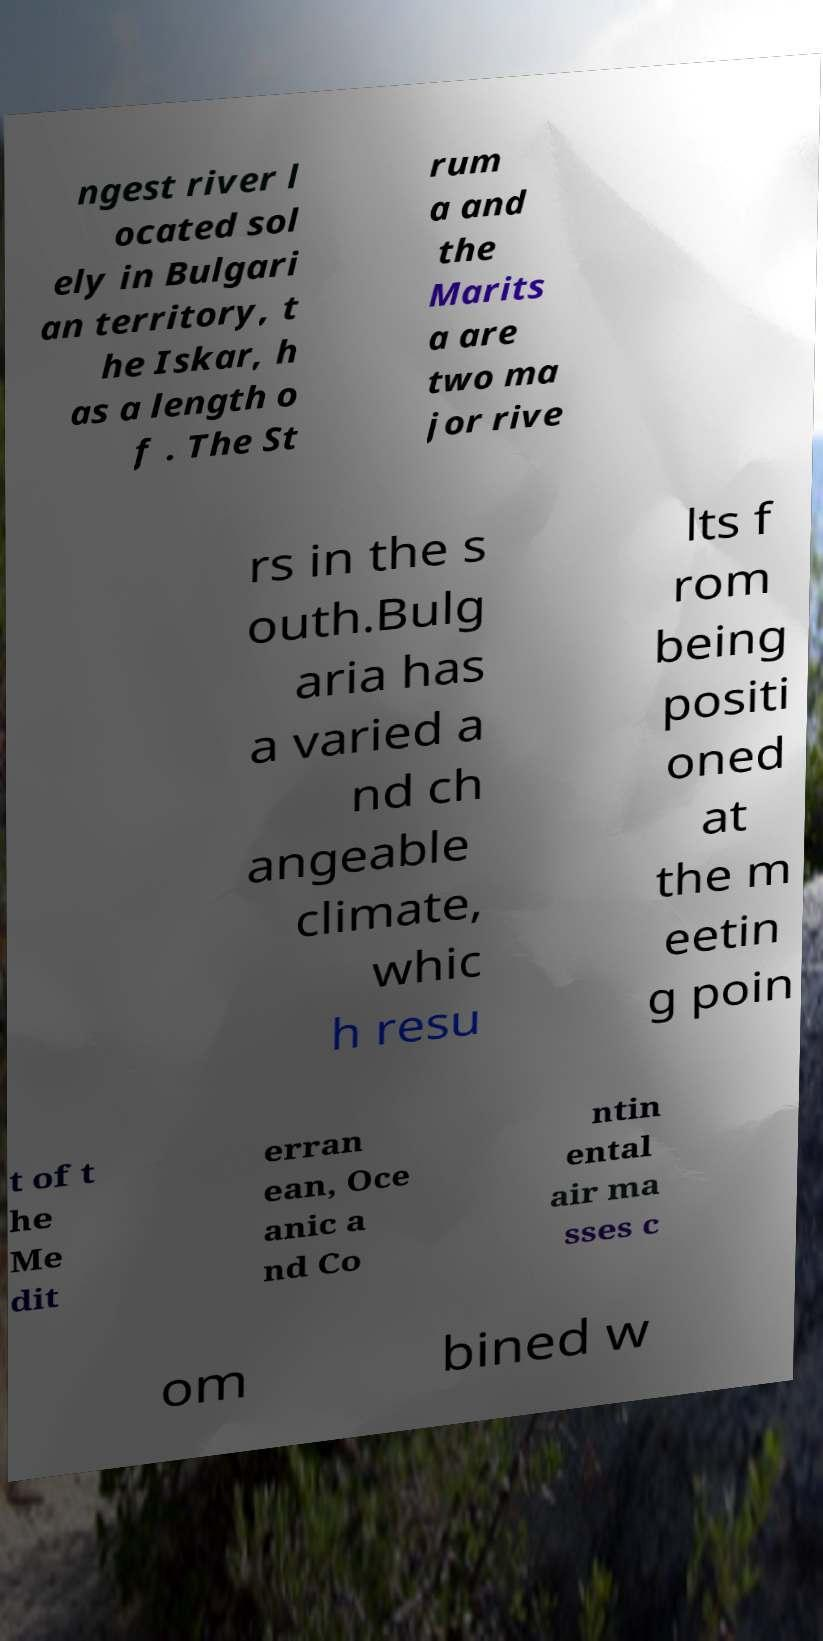Could you assist in decoding the text presented in this image and type it out clearly? ngest river l ocated sol ely in Bulgari an territory, t he Iskar, h as a length o f . The St rum a and the Marits a are two ma jor rive rs in the s outh.Bulg aria has a varied a nd ch angeable climate, whic h resu lts f rom being positi oned at the m eetin g poin t of t he Me dit erran ean, Oce anic a nd Co ntin ental air ma sses c om bined w 